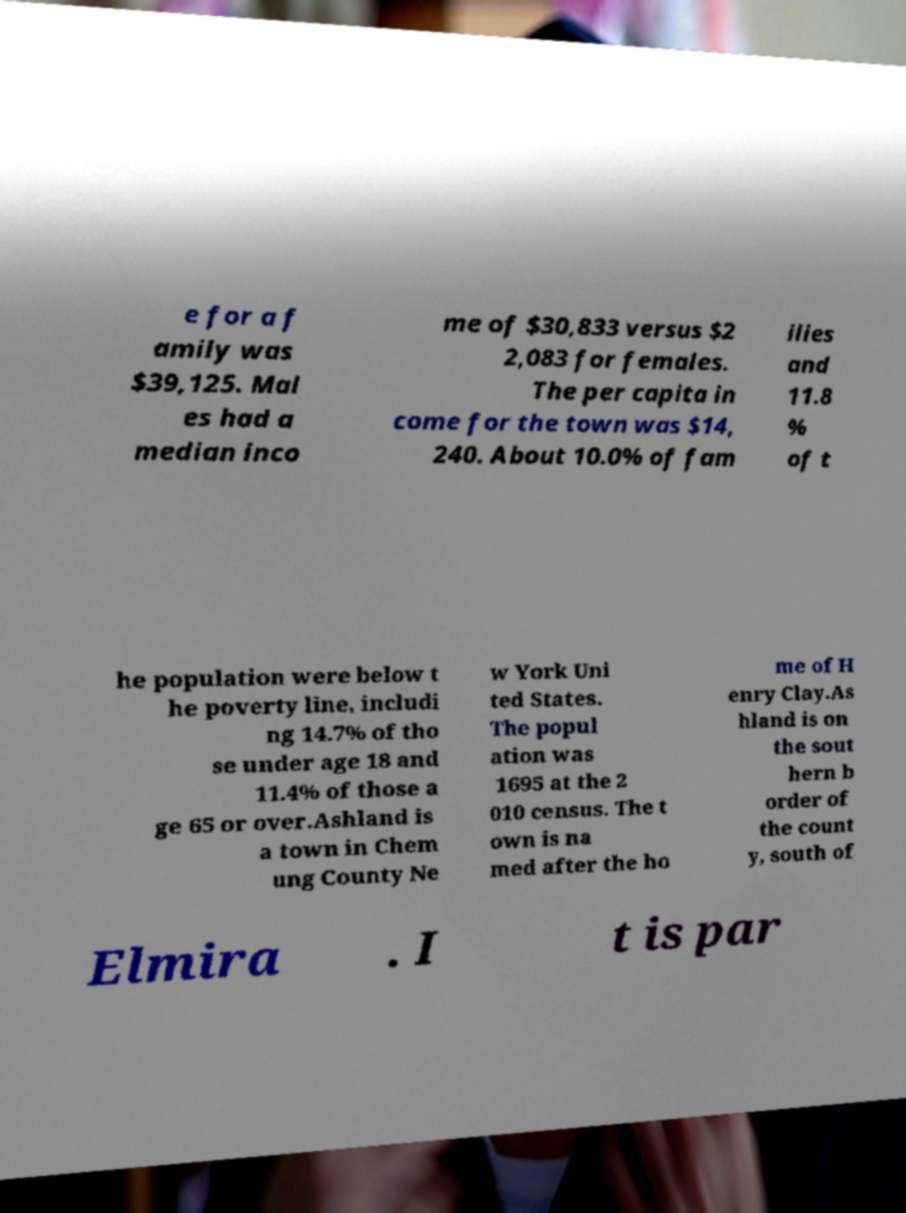Please identify and transcribe the text found in this image. e for a f amily was $39,125. Mal es had a median inco me of $30,833 versus $2 2,083 for females. The per capita in come for the town was $14, 240. About 10.0% of fam ilies and 11.8 % of t he population were below t he poverty line, includi ng 14.7% of tho se under age 18 and 11.4% of those a ge 65 or over.Ashland is a town in Chem ung County Ne w York Uni ted States. The popul ation was 1695 at the 2 010 census. The t own is na med after the ho me of H enry Clay.As hland is on the sout hern b order of the count y, south of Elmira . I t is par 